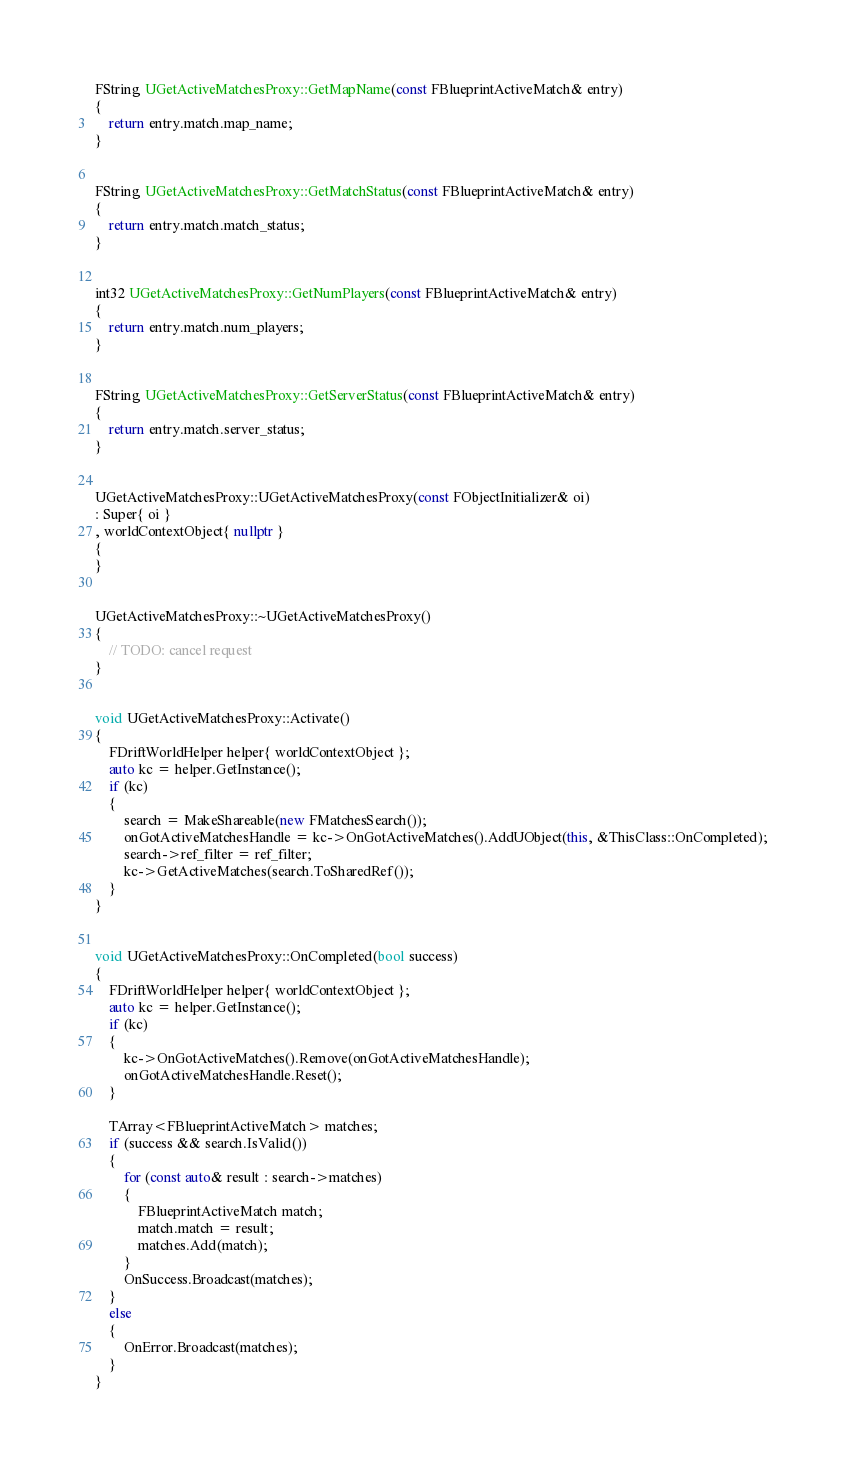Convert code to text. <code><loc_0><loc_0><loc_500><loc_500><_C++_>
FString UGetActiveMatchesProxy::GetMapName(const FBlueprintActiveMatch& entry)
{
    return entry.match.map_name;
}


FString UGetActiveMatchesProxy::GetMatchStatus(const FBlueprintActiveMatch& entry)
{
    return entry.match.match_status;
}


int32 UGetActiveMatchesProxy::GetNumPlayers(const FBlueprintActiveMatch& entry)
{
    return entry.match.num_players;
}


FString UGetActiveMatchesProxy::GetServerStatus(const FBlueprintActiveMatch& entry)
{
    return entry.match.server_status;
}


UGetActiveMatchesProxy::UGetActiveMatchesProxy(const FObjectInitializer& oi)
: Super{ oi }
, worldContextObject{ nullptr }
{
}


UGetActiveMatchesProxy::~UGetActiveMatchesProxy()
{
    // TODO: cancel request
}


void UGetActiveMatchesProxy::Activate()
{
    FDriftWorldHelper helper{ worldContextObject };
    auto kc = helper.GetInstance();
	if (kc)
	{
        search = MakeShareable(new FMatchesSearch());
		onGotActiveMatchesHandle = kc->OnGotActiveMatches().AddUObject(this, &ThisClass::OnCompleted);
        search->ref_filter = ref_filter;
		kc->GetActiveMatches(search.ToSharedRef());
	}
}


void UGetActiveMatchesProxy::OnCompleted(bool success)
{
    FDriftWorldHelper helper{ worldContextObject };
    auto kc = helper.GetInstance();
	if (kc)
	{
        kc->OnGotActiveMatches().Remove(onGotActiveMatchesHandle);
        onGotActiveMatchesHandle.Reset();
	}

	TArray<FBlueprintActiveMatch> matches;
	if (success && search.IsValid())
	{
		for (const auto& result : search->matches)
		{
			FBlueprintActiveMatch match;
            match.match = result;
			matches.Add(match);
		}
		OnSuccess.Broadcast(matches);
	}
	else
	{
        OnError.Broadcast(matches);
	}
}
</code> 